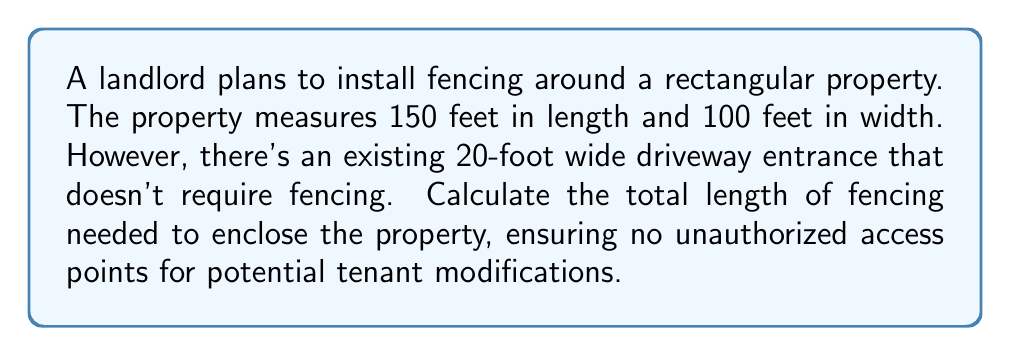Solve this math problem. Let's approach this step-by-step:

1) First, we need to calculate the perimeter of the rectangular property:
   
   Perimeter = 2 * (length + width)
   $$P = 2(l + w)$$
   $$P = 2(150 + 100) = 2(250) = 500\text{ feet}$$

2) However, we don't need to fence the driveway entrance. The driveway width is 20 feet, so we need to subtract this from our total:

   $$\text{Fencing needed} = 500 - 20 = 480\text{ feet}$$

3) To visualize this, we can draw a diagram:

   [asy]
   unitsize(0.02cm);
   draw((0,0)--(150,0)--(150,100)--(0,100)--cycle);
   draw((65,100)--(85,100),dashed);
   label("150 ft", (75,0), S);
   label("100 ft", (150,50), E);
   label("20 ft", (75,100), N);
   [/asy]

   The dashed line represents the unfenced driveway entrance.

Therefore, the total length of fencing needed is 480 feet.
Answer: 480 feet 